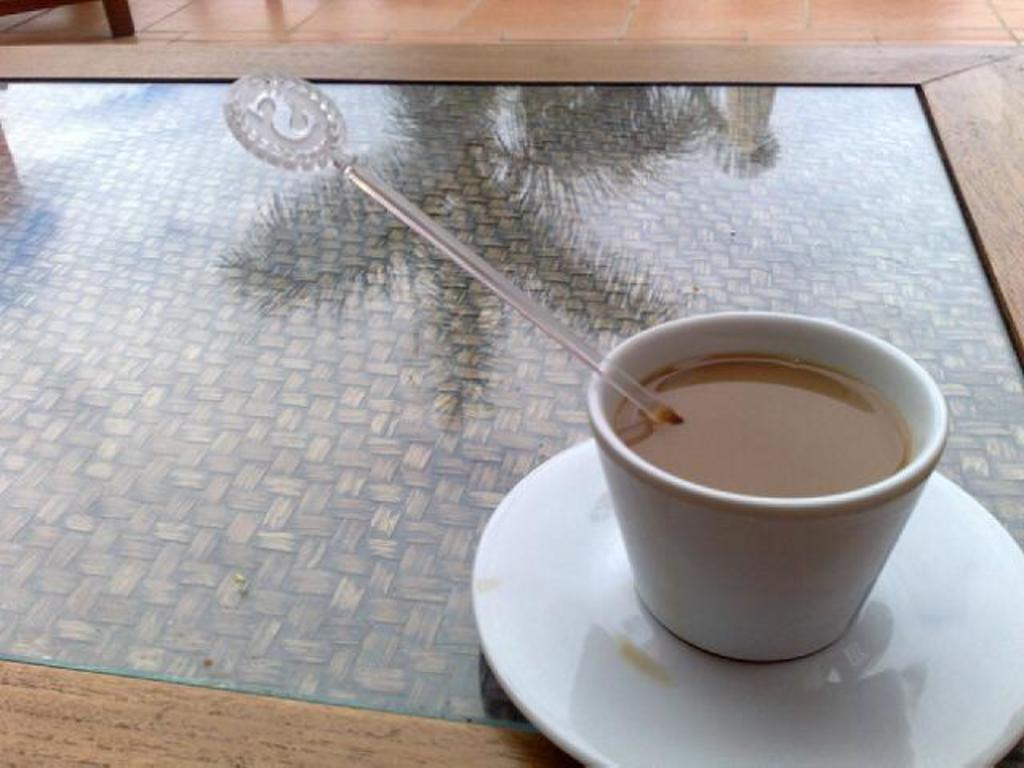Can you describe this image briefly? In this picture we can see a table and on table we have cup with tea in it, saucer, stick and in background we can see floor, table leg. 